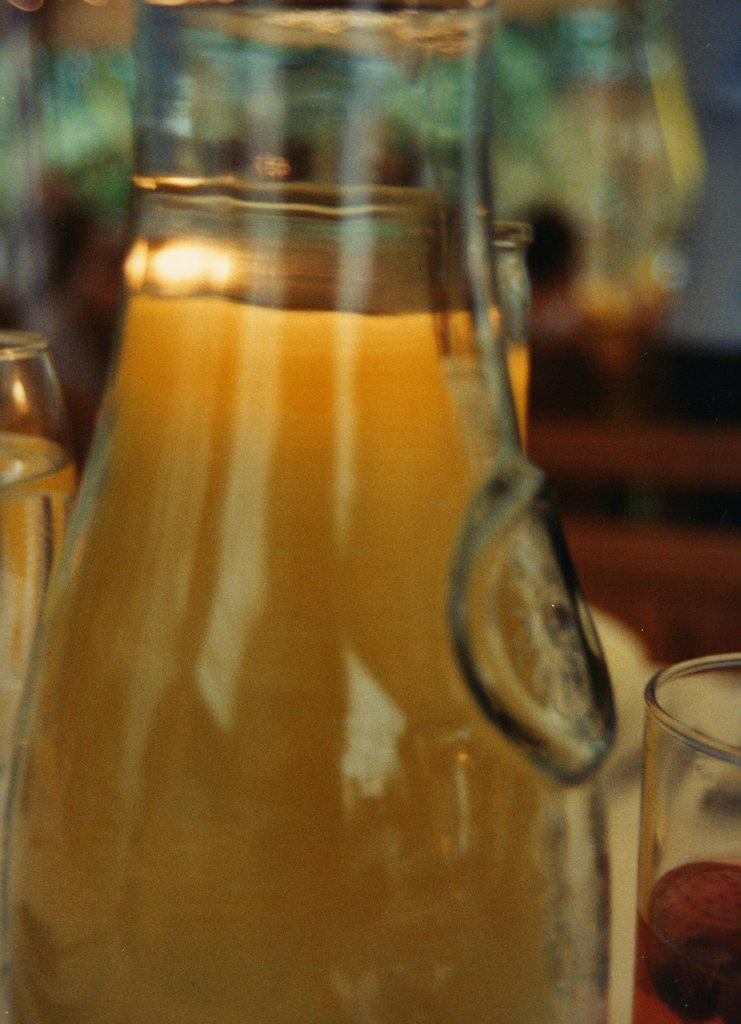What is contained within the bottle in the image? There is a drink in the bottle in the image. How much of the drink is in the bottle? The bottle is filled with the drink. What is placed on the table in the image? There is a glass placed on the table in the image. What word is written on the bottle in the image? There is no word written on the bottle in the image. What type of beast can be seen interacting with the glass on the table? There is no beast present in the image; it only features a bottle with a drink and a glass on the table. 